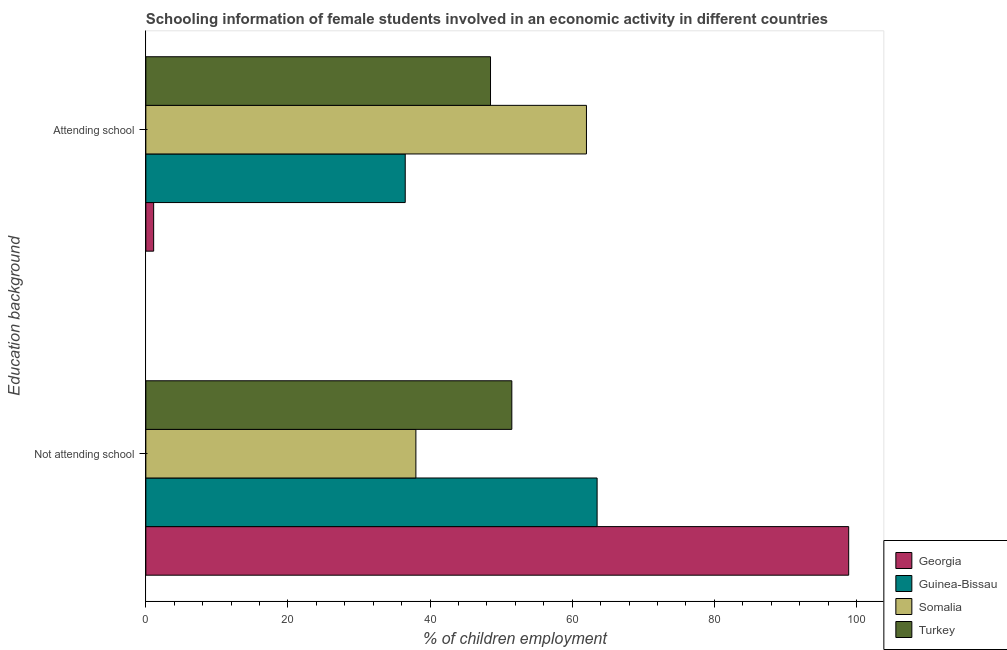How many different coloured bars are there?
Offer a terse response. 4. Are the number of bars per tick equal to the number of legend labels?
Your answer should be compact. Yes. Are the number of bars on each tick of the Y-axis equal?
Give a very brief answer. Yes. What is the label of the 1st group of bars from the top?
Provide a short and direct response. Attending school. What is the percentage of employed females who are attending school in Georgia?
Your response must be concise. 1.1. Across all countries, what is the maximum percentage of employed females who are not attending school?
Keep it short and to the point. 98.9. In which country was the percentage of employed females who are attending school maximum?
Give a very brief answer. Somalia. In which country was the percentage of employed females who are attending school minimum?
Offer a very short reply. Georgia. What is the total percentage of employed females who are not attending school in the graph?
Ensure brevity in your answer.  251.9. What is the difference between the percentage of employed females who are not attending school in Guinea-Bissau and that in Somalia?
Keep it short and to the point. 25.5. What is the difference between the percentage of employed females who are attending school in Georgia and the percentage of employed females who are not attending school in Turkey?
Offer a terse response. -50.4. What is the average percentage of employed females who are attending school per country?
Ensure brevity in your answer.  37.02. What is the difference between the percentage of employed females who are not attending school and percentage of employed females who are attending school in Georgia?
Provide a succinct answer. 97.8. What is the ratio of the percentage of employed females who are attending school in Guinea-Bissau to that in Georgia?
Provide a short and direct response. 33.18. Is the percentage of employed females who are not attending school in Georgia less than that in Somalia?
Provide a short and direct response. No. In how many countries, is the percentage of employed females who are attending school greater than the average percentage of employed females who are attending school taken over all countries?
Provide a succinct answer. 2. What does the 4th bar from the top in Not attending school represents?
Provide a succinct answer. Georgia. What does the 1st bar from the bottom in Not attending school represents?
Provide a short and direct response. Georgia. Are all the bars in the graph horizontal?
Your response must be concise. Yes. How many countries are there in the graph?
Offer a very short reply. 4. Does the graph contain any zero values?
Your answer should be compact. No. Where does the legend appear in the graph?
Keep it short and to the point. Bottom right. What is the title of the graph?
Your answer should be very brief. Schooling information of female students involved in an economic activity in different countries. What is the label or title of the X-axis?
Give a very brief answer. % of children employment. What is the label or title of the Y-axis?
Provide a succinct answer. Education background. What is the % of children employment in Georgia in Not attending school?
Your answer should be compact. 98.9. What is the % of children employment in Guinea-Bissau in Not attending school?
Offer a terse response. 63.5. What is the % of children employment of Turkey in Not attending school?
Provide a succinct answer. 51.5. What is the % of children employment of Guinea-Bissau in Attending school?
Make the answer very short. 36.5. What is the % of children employment in Turkey in Attending school?
Ensure brevity in your answer.  48.5. Across all Education background, what is the maximum % of children employment in Georgia?
Your answer should be compact. 98.9. Across all Education background, what is the maximum % of children employment of Guinea-Bissau?
Provide a short and direct response. 63.5. Across all Education background, what is the maximum % of children employment in Somalia?
Your answer should be very brief. 62. Across all Education background, what is the maximum % of children employment in Turkey?
Keep it short and to the point. 51.5. Across all Education background, what is the minimum % of children employment of Guinea-Bissau?
Make the answer very short. 36.5. Across all Education background, what is the minimum % of children employment of Turkey?
Your answer should be very brief. 48.5. What is the total % of children employment of Georgia in the graph?
Provide a short and direct response. 100. What is the total % of children employment of Guinea-Bissau in the graph?
Your response must be concise. 100. What is the total % of children employment of Somalia in the graph?
Offer a terse response. 100. What is the total % of children employment of Turkey in the graph?
Offer a very short reply. 100. What is the difference between the % of children employment in Georgia in Not attending school and that in Attending school?
Ensure brevity in your answer.  97.8. What is the difference between the % of children employment of Turkey in Not attending school and that in Attending school?
Ensure brevity in your answer.  3. What is the difference between the % of children employment of Georgia in Not attending school and the % of children employment of Guinea-Bissau in Attending school?
Offer a terse response. 62.4. What is the difference between the % of children employment in Georgia in Not attending school and the % of children employment in Somalia in Attending school?
Provide a short and direct response. 36.9. What is the difference between the % of children employment of Georgia in Not attending school and the % of children employment of Turkey in Attending school?
Provide a short and direct response. 50.4. What is the difference between the % of children employment of Guinea-Bissau in Not attending school and the % of children employment of Somalia in Attending school?
Ensure brevity in your answer.  1.5. What is the average % of children employment in Georgia per Education background?
Offer a very short reply. 50. What is the difference between the % of children employment of Georgia and % of children employment of Guinea-Bissau in Not attending school?
Ensure brevity in your answer.  35.4. What is the difference between the % of children employment in Georgia and % of children employment in Somalia in Not attending school?
Your response must be concise. 60.9. What is the difference between the % of children employment of Georgia and % of children employment of Turkey in Not attending school?
Give a very brief answer. 47.4. What is the difference between the % of children employment in Guinea-Bissau and % of children employment in Turkey in Not attending school?
Your response must be concise. 12. What is the difference between the % of children employment of Somalia and % of children employment of Turkey in Not attending school?
Offer a very short reply. -13.5. What is the difference between the % of children employment in Georgia and % of children employment in Guinea-Bissau in Attending school?
Provide a succinct answer. -35.4. What is the difference between the % of children employment in Georgia and % of children employment in Somalia in Attending school?
Your answer should be compact. -60.9. What is the difference between the % of children employment of Georgia and % of children employment of Turkey in Attending school?
Provide a short and direct response. -47.4. What is the difference between the % of children employment in Guinea-Bissau and % of children employment in Somalia in Attending school?
Offer a terse response. -25.5. What is the ratio of the % of children employment in Georgia in Not attending school to that in Attending school?
Make the answer very short. 89.91. What is the ratio of the % of children employment of Guinea-Bissau in Not attending school to that in Attending school?
Provide a succinct answer. 1.74. What is the ratio of the % of children employment of Somalia in Not attending school to that in Attending school?
Make the answer very short. 0.61. What is the ratio of the % of children employment of Turkey in Not attending school to that in Attending school?
Ensure brevity in your answer.  1.06. What is the difference between the highest and the second highest % of children employment in Georgia?
Offer a terse response. 97.8. What is the difference between the highest and the second highest % of children employment of Guinea-Bissau?
Make the answer very short. 27. What is the difference between the highest and the second highest % of children employment in Somalia?
Keep it short and to the point. 24. What is the difference between the highest and the second highest % of children employment in Turkey?
Give a very brief answer. 3. What is the difference between the highest and the lowest % of children employment in Georgia?
Give a very brief answer. 97.8. What is the difference between the highest and the lowest % of children employment in Somalia?
Your answer should be very brief. 24. What is the difference between the highest and the lowest % of children employment of Turkey?
Provide a short and direct response. 3. 